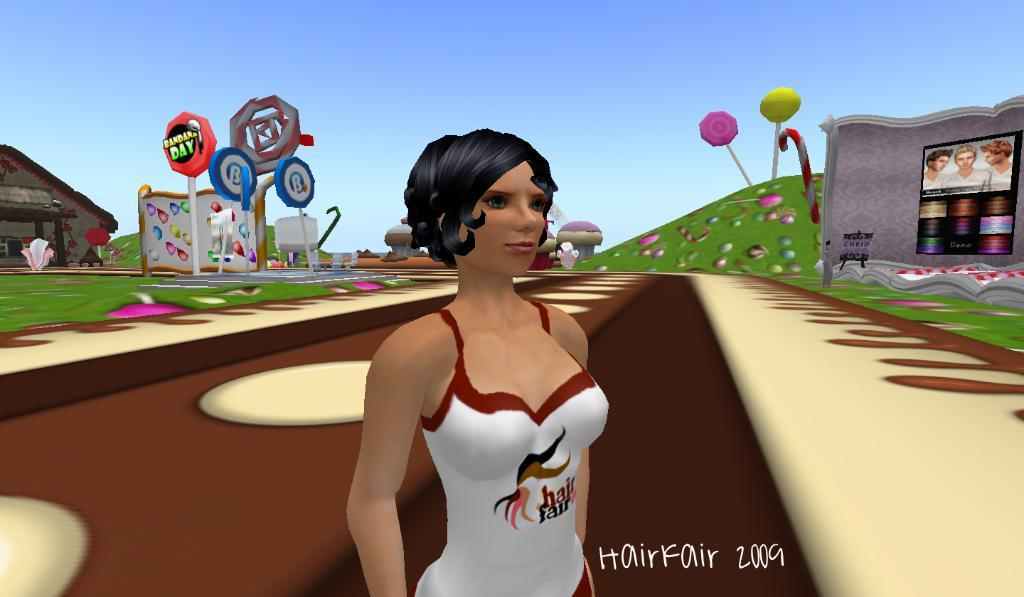What type of picture is the image? The image is an animated picture. Can you describe the main subject in the image? There is a person in the image. What can be seen in the background of the image? There are boards, grass, a house, and the sky visible in the background of the image. What type of straw is the person using to read a book in the image? There is no straw or book present in the image; it features an animated person in a background with boards, grass, a house, and the sky. Can you tell me how many grandmothers are in the image? There is no grandmother present in the image; it features an animated person in a background with boards, grass, a house, and the sky. 